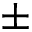<formula> <loc_0><loc_0><loc_500><loc_500>\pm</formula> 